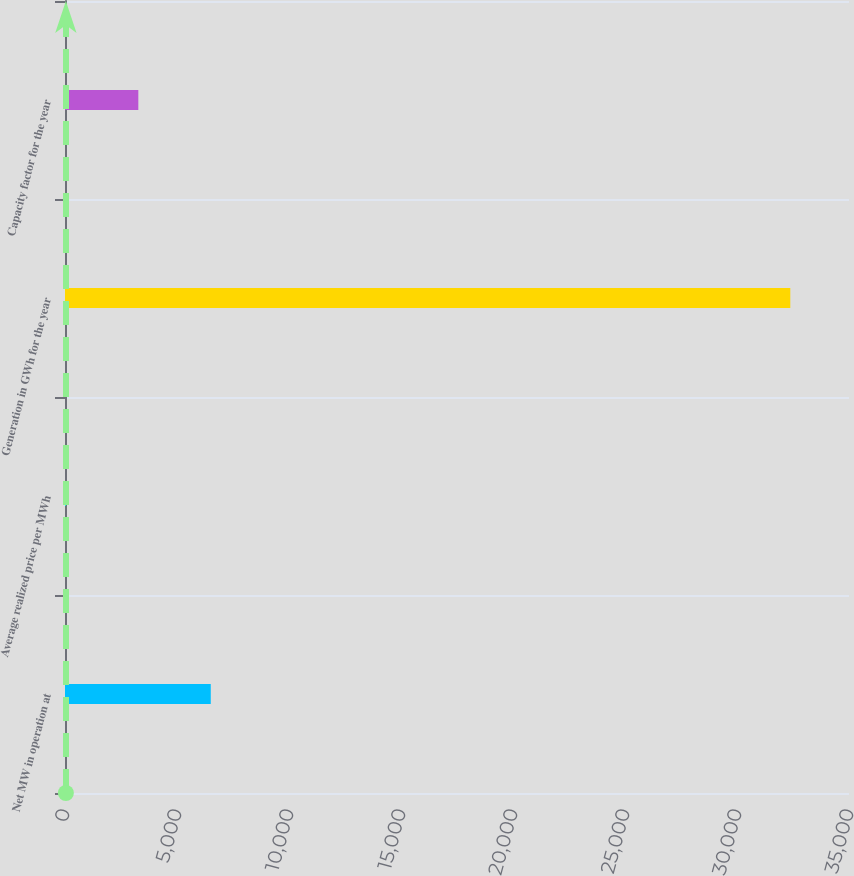<chart> <loc_0><loc_0><loc_500><loc_500><bar_chart><fcel>Net MW in operation at<fcel>Average realized price per MWh<fcel>Generation in GWh for the year<fcel>Capacity factor for the year<nl><fcel>6507.3<fcel>39.38<fcel>32379<fcel>3273.34<nl></chart> 